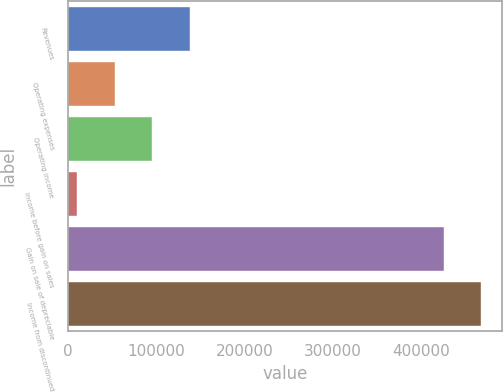Convert chart. <chart><loc_0><loc_0><loc_500><loc_500><bar_chart><fcel>Revenues<fcel>Operating expenses<fcel>Operating income<fcel>Income before gain on sales<fcel>Gain on sale of depreciable<fcel>Income from discontinued<nl><fcel>138407<fcel>53428.2<fcel>95917.4<fcel>10939<fcel>424892<fcel>467381<nl></chart> 